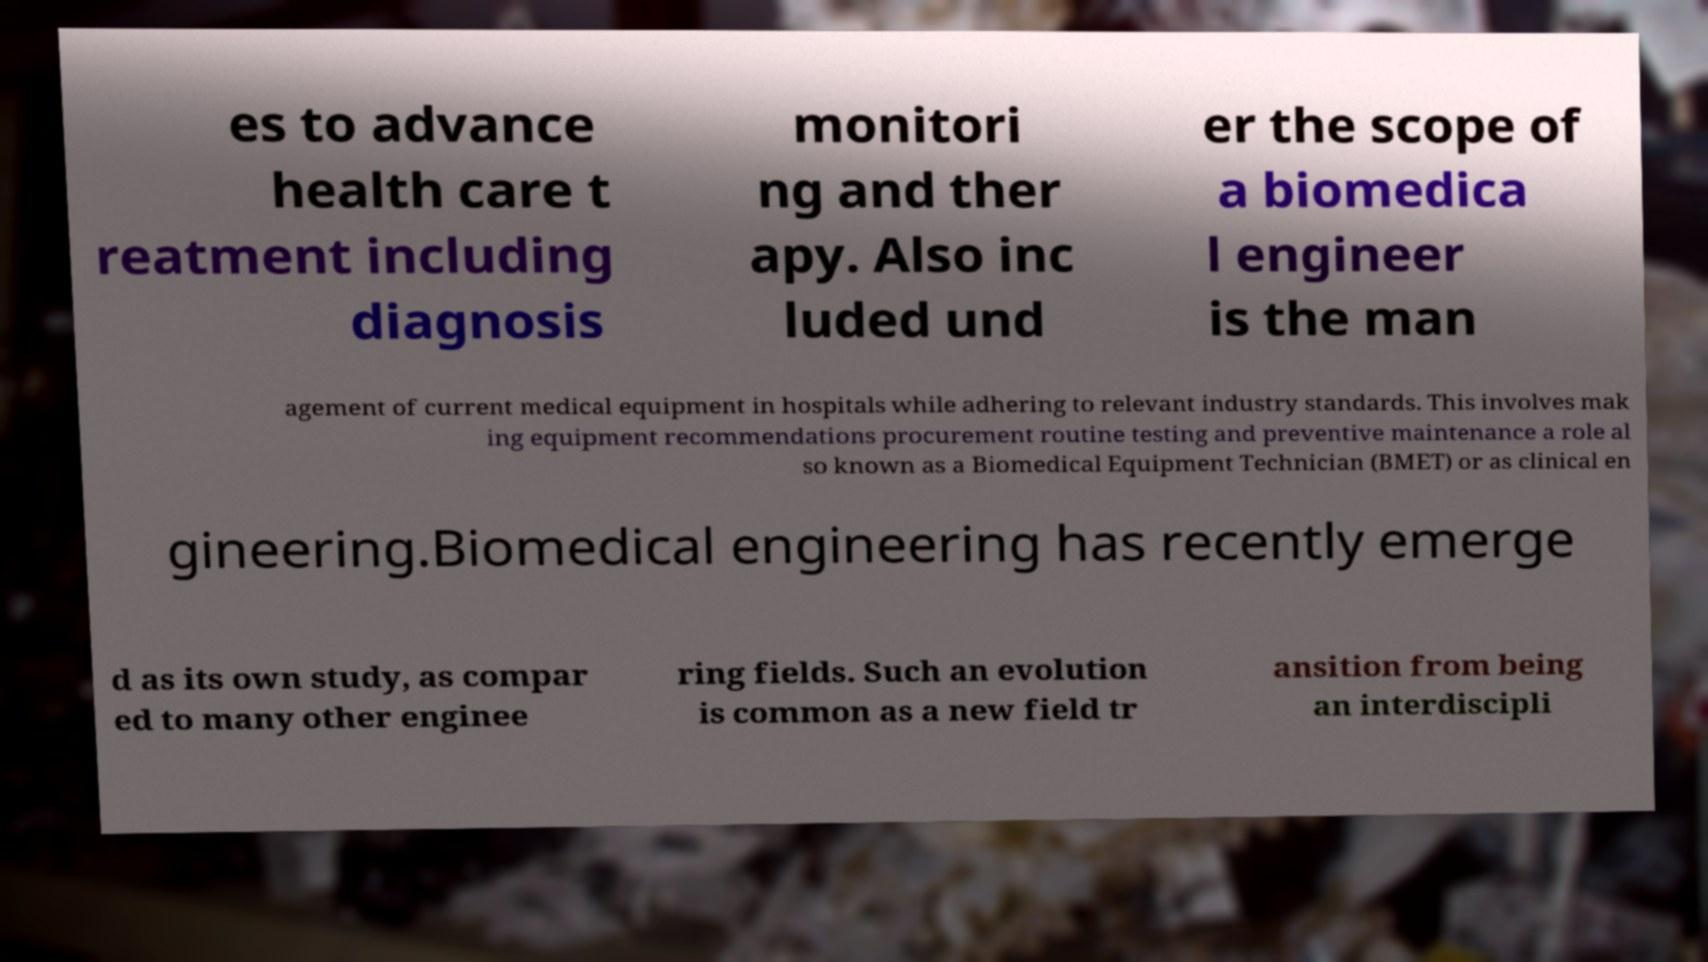Please read and relay the text visible in this image. What does it say? es to advance health care t reatment including diagnosis monitori ng and ther apy. Also inc luded und er the scope of a biomedica l engineer is the man agement of current medical equipment in hospitals while adhering to relevant industry standards. This involves mak ing equipment recommendations procurement routine testing and preventive maintenance a role al so known as a Biomedical Equipment Technician (BMET) or as clinical en gineering.Biomedical engineering has recently emerge d as its own study, as compar ed to many other enginee ring fields. Such an evolution is common as a new field tr ansition from being an interdiscipli 